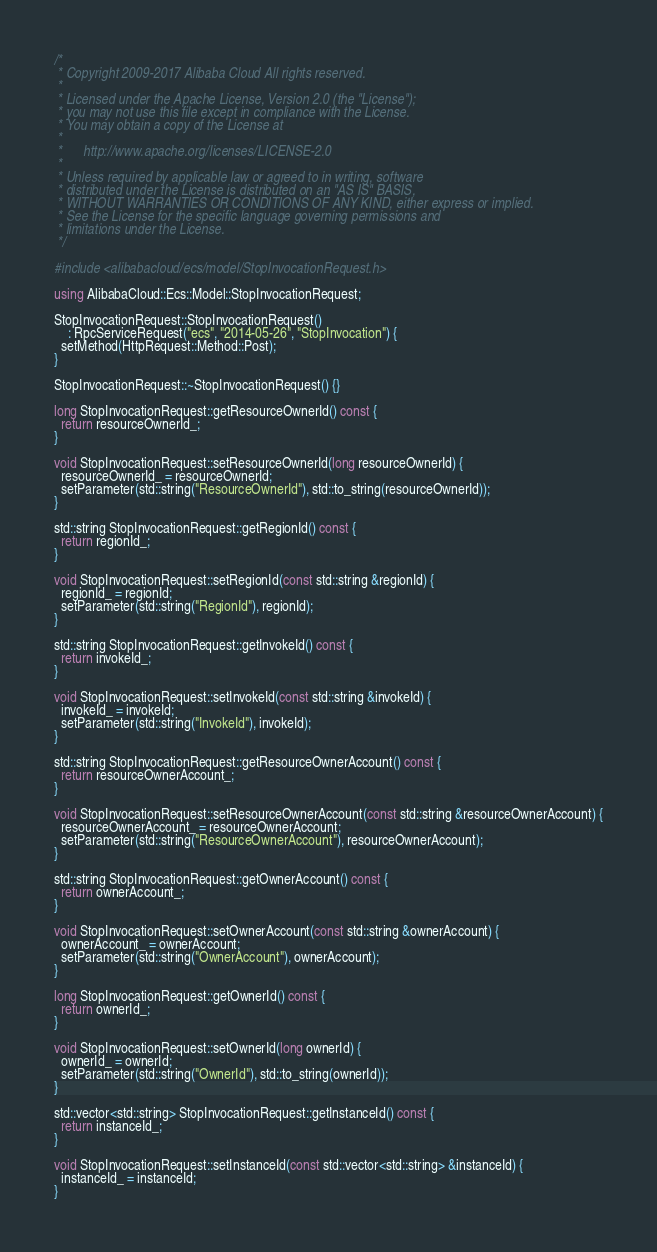<code> <loc_0><loc_0><loc_500><loc_500><_C++_>/*
 * Copyright 2009-2017 Alibaba Cloud All rights reserved.
 *
 * Licensed under the Apache License, Version 2.0 (the "License");
 * you may not use this file except in compliance with the License.
 * You may obtain a copy of the License at
 *
 *      http://www.apache.org/licenses/LICENSE-2.0
 *
 * Unless required by applicable law or agreed to in writing, software
 * distributed under the License is distributed on an "AS IS" BASIS,
 * WITHOUT WARRANTIES OR CONDITIONS OF ANY KIND, either express or implied.
 * See the License for the specific language governing permissions and
 * limitations under the License.
 */

#include <alibabacloud/ecs/model/StopInvocationRequest.h>

using AlibabaCloud::Ecs::Model::StopInvocationRequest;

StopInvocationRequest::StopInvocationRequest()
    : RpcServiceRequest("ecs", "2014-05-26", "StopInvocation") {
  setMethod(HttpRequest::Method::Post);
}

StopInvocationRequest::~StopInvocationRequest() {}

long StopInvocationRequest::getResourceOwnerId() const {
  return resourceOwnerId_;
}

void StopInvocationRequest::setResourceOwnerId(long resourceOwnerId) {
  resourceOwnerId_ = resourceOwnerId;
  setParameter(std::string("ResourceOwnerId"), std::to_string(resourceOwnerId));
}

std::string StopInvocationRequest::getRegionId() const {
  return regionId_;
}

void StopInvocationRequest::setRegionId(const std::string &regionId) {
  regionId_ = regionId;
  setParameter(std::string("RegionId"), regionId);
}

std::string StopInvocationRequest::getInvokeId() const {
  return invokeId_;
}

void StopInvocationRequest::setInvokeId(const std::string &invokeId) {
  invokeId_ = invokeId;
  setParameter(std::string("InvokeId"), invokeId);
}

std::string StopInvocationRequest::getResourceOwnerAccount() const {
  return resourceOwnerAccount_;
}

void StopInvocationRequest::setResourceOwnerAccount(const std::string &resourceOwnerAccount) {
  resourceOwnerAccount_ = resourceOwnerAccount;
  setParameter(std::string("ResourceOwnerAccount"), resourceOwnerAccount);
}

std::string StopInvocationRequest::getOwnerAccount() const {
  return ownerAccount_;
}

void StopInvocationRequest::setOwnerAccount(const std::string &ownerAccount) {
  ownerAccount_ = ownerAccount;
  setParameter(std::string("OwnerAccount"), ownerAccount);
}

long StopInvocationRequest::getOwnerId() const {
  return ownerId_;
}

void StopInvocationRequest::setOwnerId(long ownerId) {
  ownerId_ = ownerId;
  setParameter(std::string("OwnerId"), std::to_string(ownerId));
}

std::vector<std::string> StopInvocationRequest::getInstanceId() const {
  return instanceId_;
}

void StopInvocationRequest::setInstanceId(const std::vector<std::string> &instanceId) {
  instanceId_ = instanceId;
}

</code> 